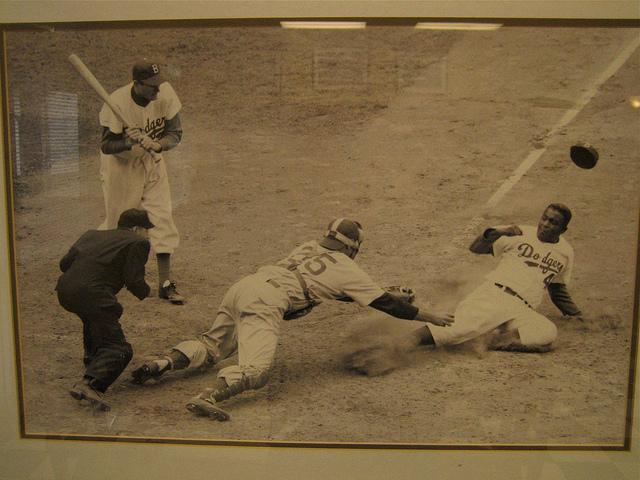Is the batter in the batters box?
Answer briefly. No. Is this a recent photo?
Write a very short answer. No. How many people are in this photo?
Answer briefly. 4. What base is the runner sliding into?
Answer briefly. Home. What are the names of the teams?
Be succinct. Dodgers. How many people are shown?
Concise answer only. 4. Is he going to catch it?
Be succinct. No. What team is at bat?
Write a very short answer. Dodgers. 